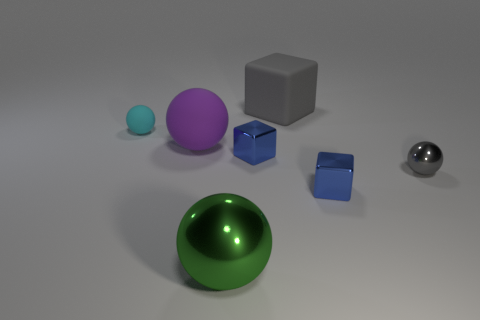Subtract 1 spheres. How many spheres are left? 3 Add 1 tiny yellow rubber objects. How many objects exist? 8 Subtract all cubes. How many objects are left? 4 Add 4 blue metallic blocks. How many blue metallic blocks are left? 6 Add 5 purple metal balls. How many purple metal balls exist? 5 Subtract 0 blue balls. How many objects are left? 7 Subtract all tiny purple matte objects. Subtract all cyan matte objects. How many objects are left? 6 